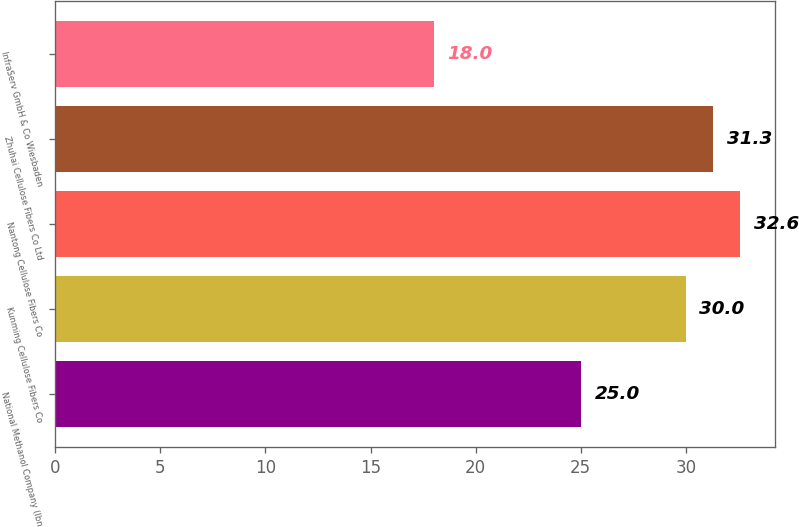Convert chart to OTSL. <chart><loc_0><loc_0><loc_500><loc_500><bar_chart><fcel>National Methanol Company (Ibn<fcel>Kunming Cellulose Fibers Co<fcel>Nantong Cellulose Fibers Co<fcel>Zhuhai Cellulose Fibers Co Ltd<fcel>InfraServ GmbH & Co Wiesbaden<nl><fcel>25<fcel>30<fcel>32.6<fcel>31.3<fcel>18<nl></chart> 